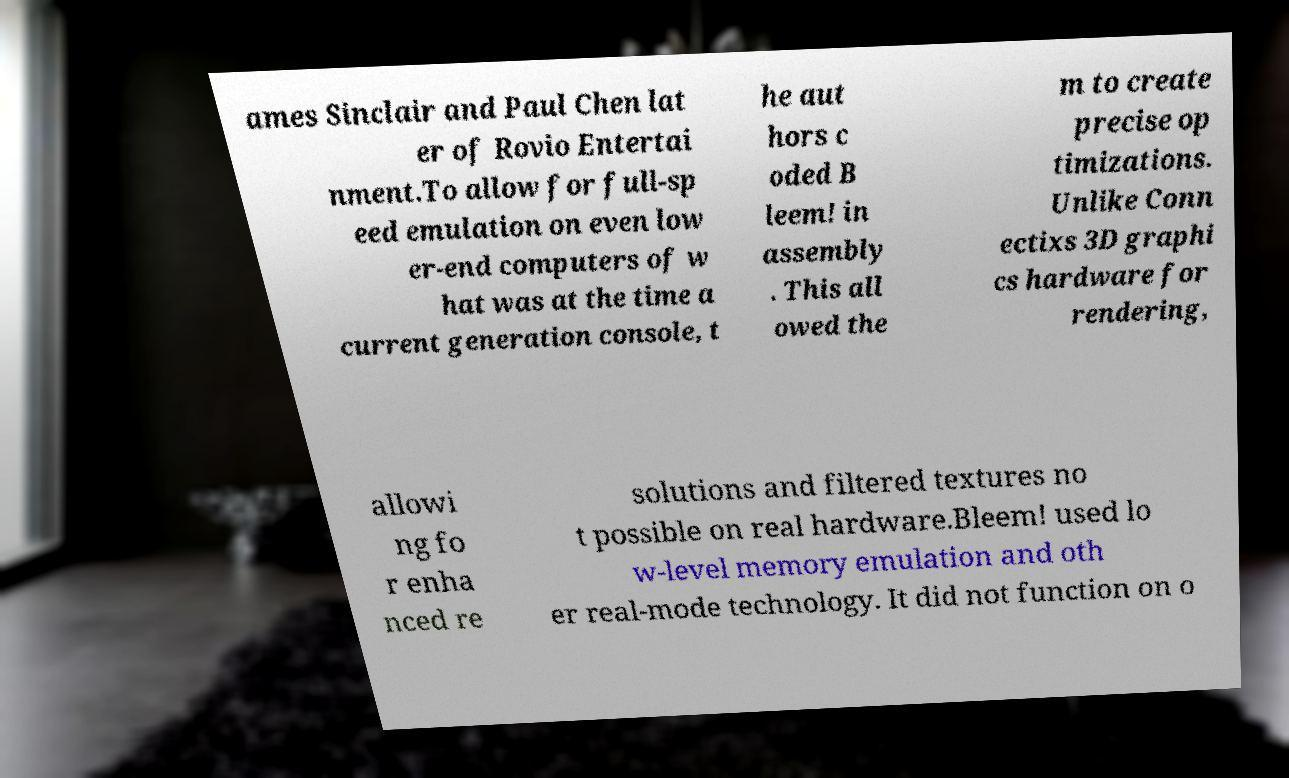Could you assist in decoding the text presented in this image and type it out clearly? ames Sinclair and Paul Chen lat er of Rovio Entertai nment.To allow for full-sp eed emulation on even low er-end computers of w hat was at the time a current generation console, t he aut hors c oded B leem! in assembly . This all owed the m to create precise op timizations. Unlike Conn ectixs 3D graphi cs hardware for rendering, allowi ng fo r enha nced re solutions and filtered textures no t possible on real hardware.Bleem! used lo w-level memory emulation and oth er real-mode technology. It did not function on o 